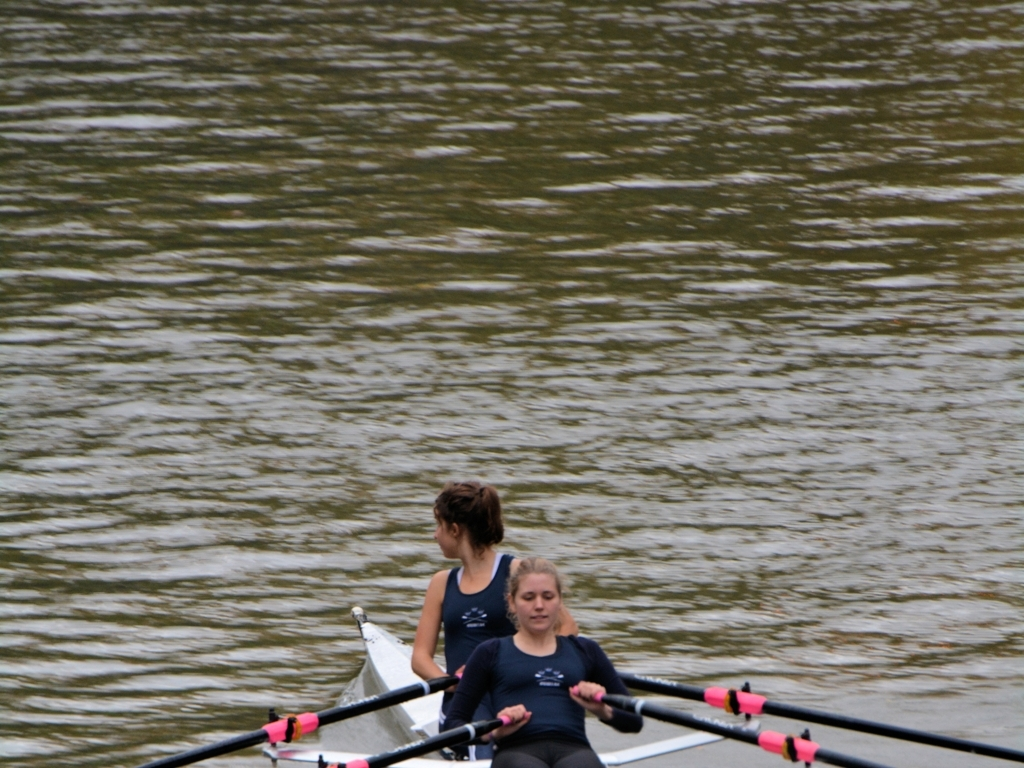What can you infer about the setting and time of day of this rowing session? Judging by the softness of the light and the lack of harsh shadows, it seems the image was taken either early in the morning or later in the afternoon, when the sunlight is less intense. The tranquil water and light overcast suggest a peaceful, early morning practice session, which is a common time for rowers to train due to calmer water conditions. Describe the impact of the environment on the athletes' performance. The calm water conditions and moderate light are ideal for rowing, allowing athletes to focus on technique without the challenge of choppy water or glaring sun. Such conditions help in maintaining consistent stroke rates and power application, critical for effective training and performance. 